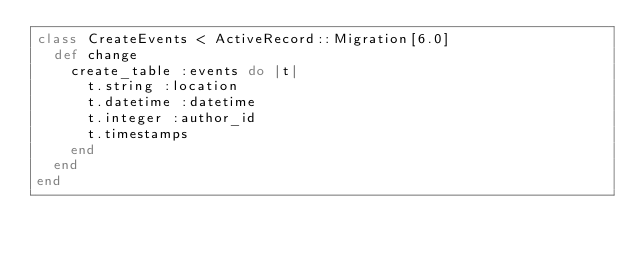<code> <loc_0><loc_0><loc_500><loc_500><_Ruby_>class CreateEvents < ActiveRecord::Migration[6.0]
  def change
    create_table :events do |t|
      t.string :location
      t.datetime :datetime
      t.integer :author_id
      t.timestamps
    end
  end
end
</code> 